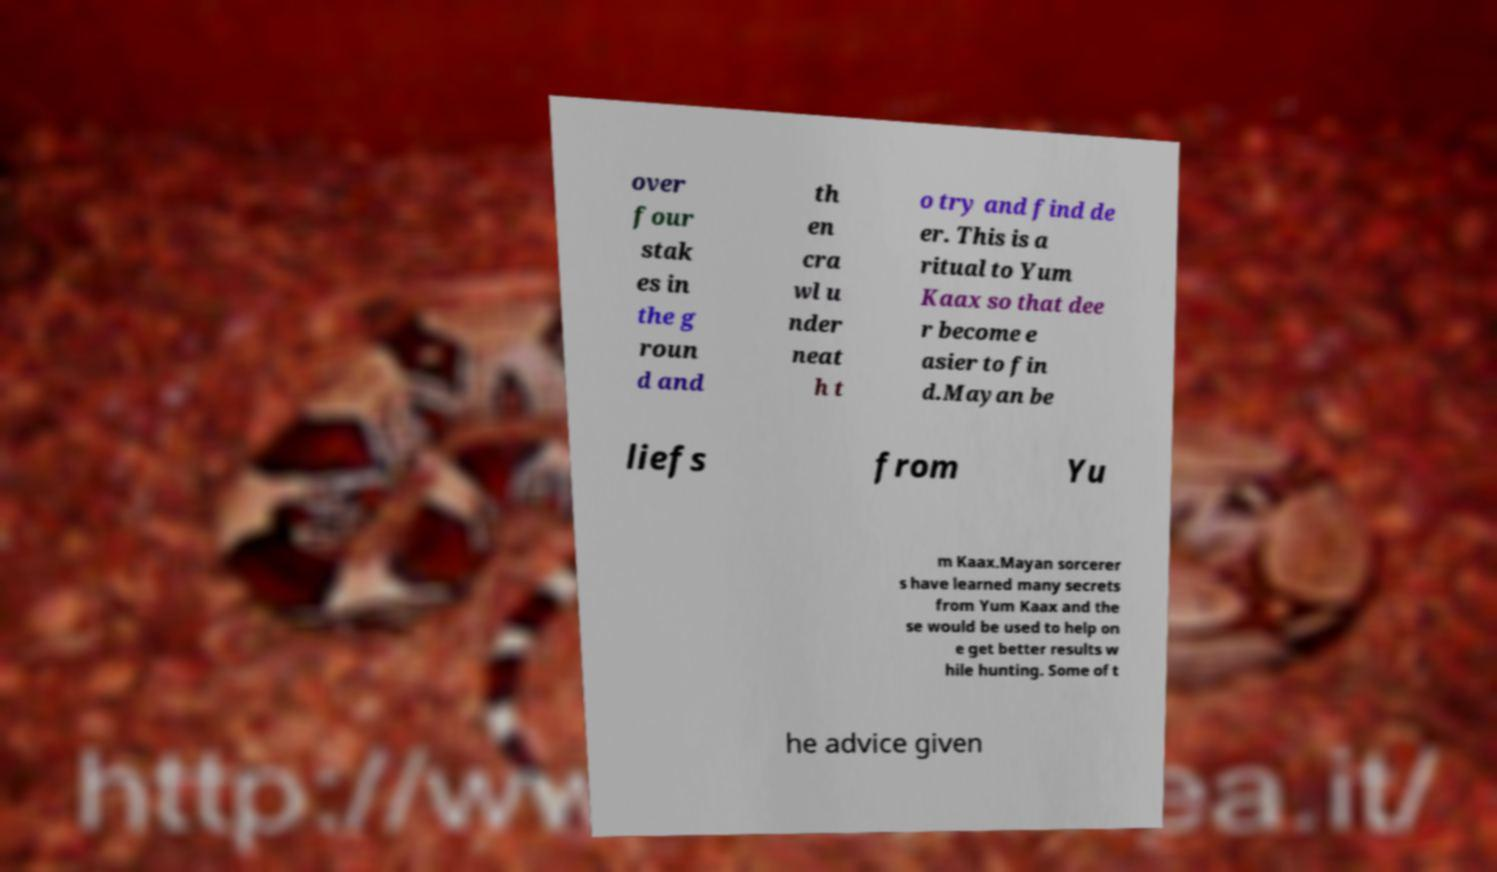For documentation purposes, I need the text within this image transcribed. Could you provide that? over four stak es in the g roun d and th en cra wl u nder neat h t o try and find de er. This is a ritual to Yum Kaax so that dee r become e asier to fin d.Mayan be liefs from Yu m Kaax.Mayan sorcerer s have learned many secrets from Yum Kaax and the se would be used to help on e get better results w hile hunting. Some of t he advice given 